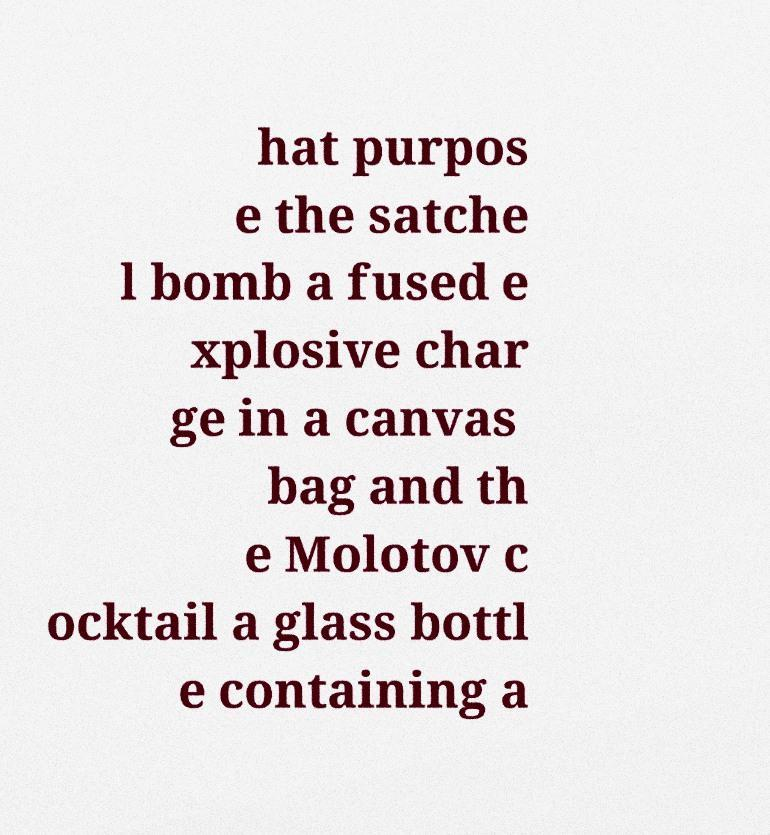Can you read and provide the text displayed in the image?This photo seems to have some interesting text. Can you extract and type it out for me? hat purpos e the satche l bomb a fused e xplosive char ge in a canvas bag and th e Molotov c ocktail a glass bottl e containing a 